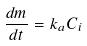Convert formula to latex. <formula><loc_0><loc_0><loc_500><loc_500>\frac { d m } { d t } = k _ { a } C _ { i }</formula> 